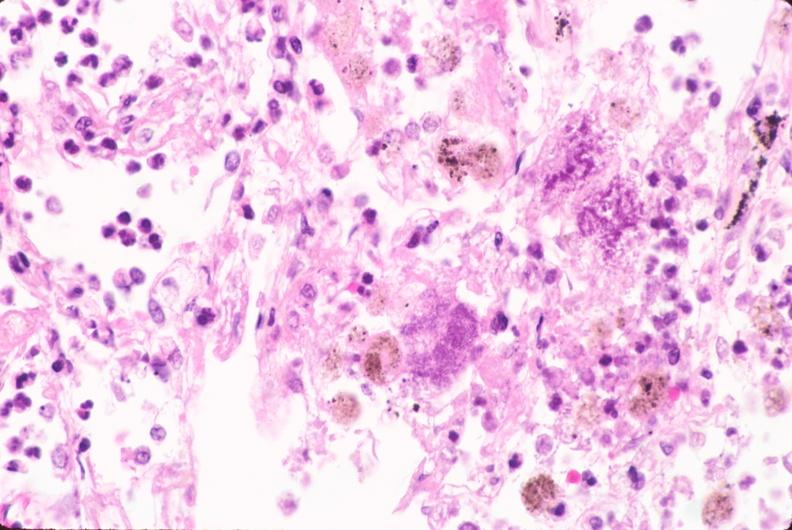what is present?
Answer the question using a single word or phrase. Respiratory 